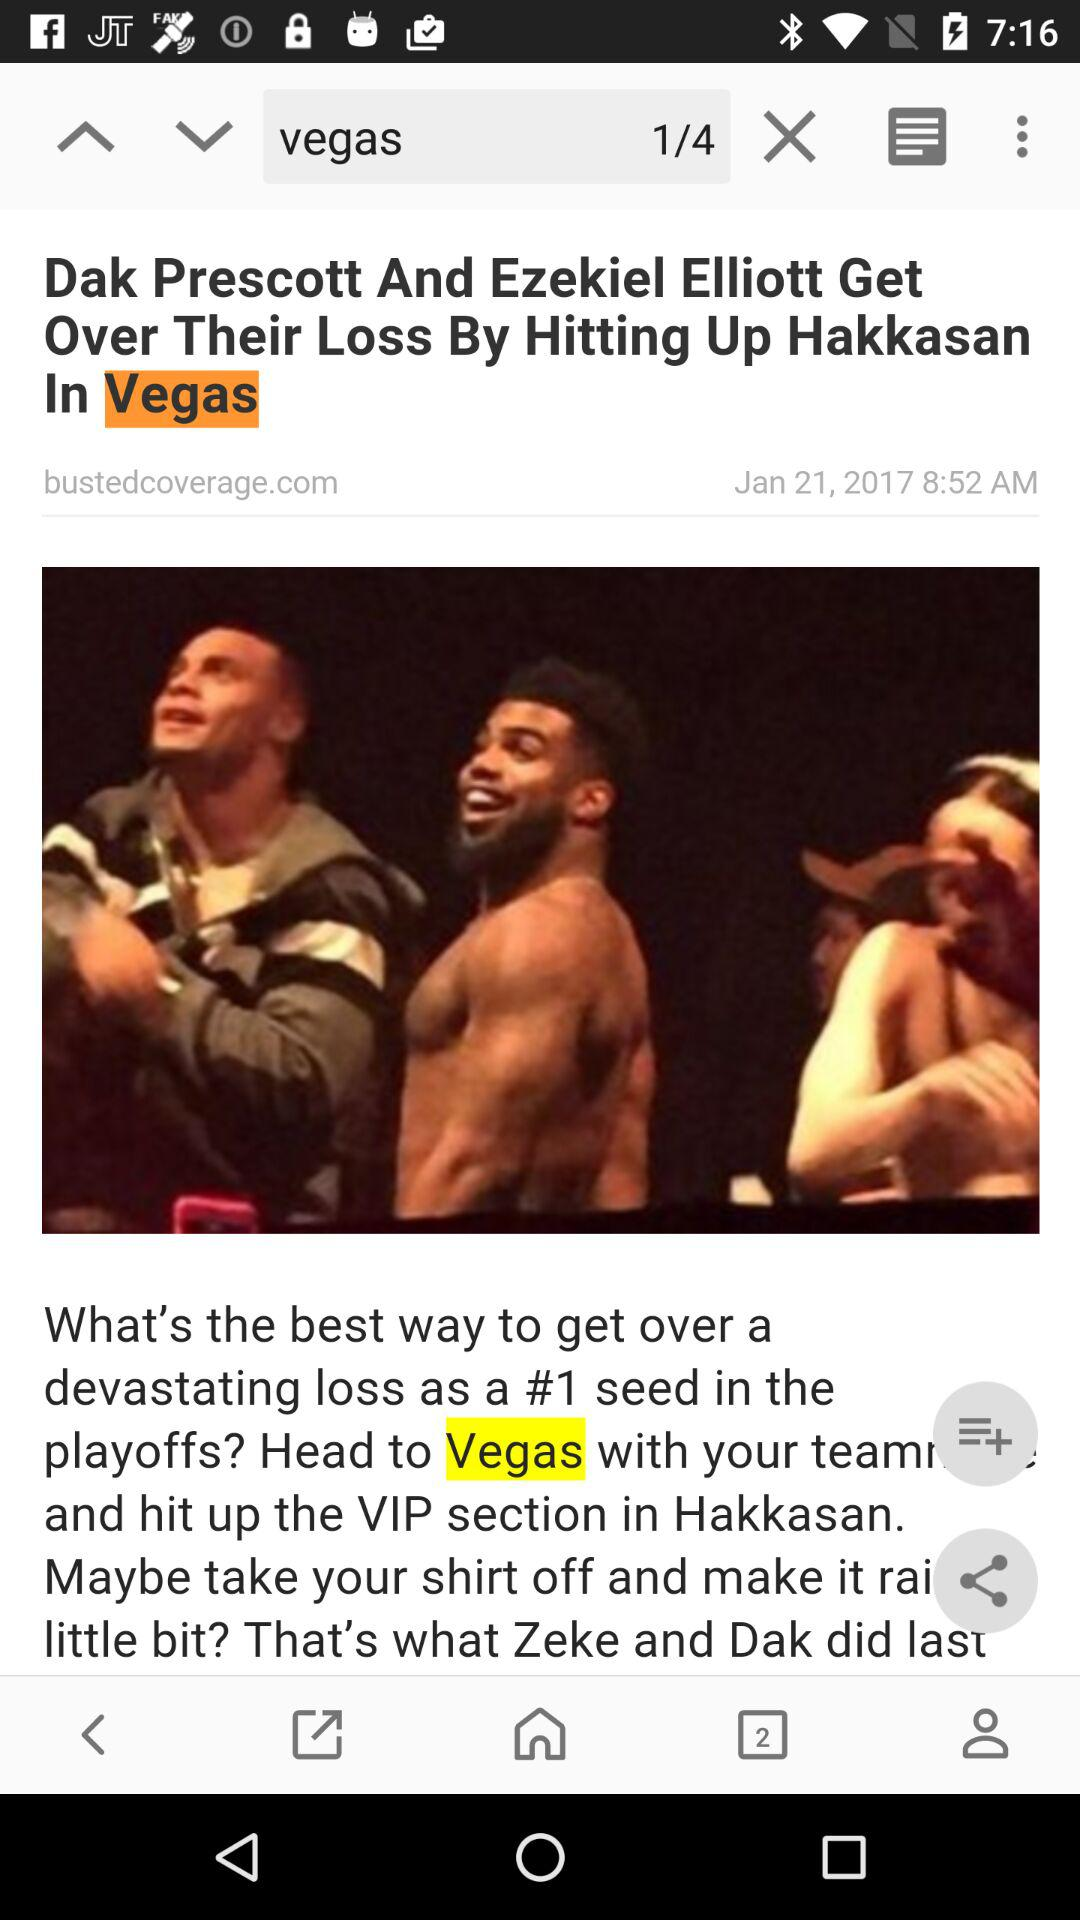Which number of "vegas" am I on? You are on number 1. 